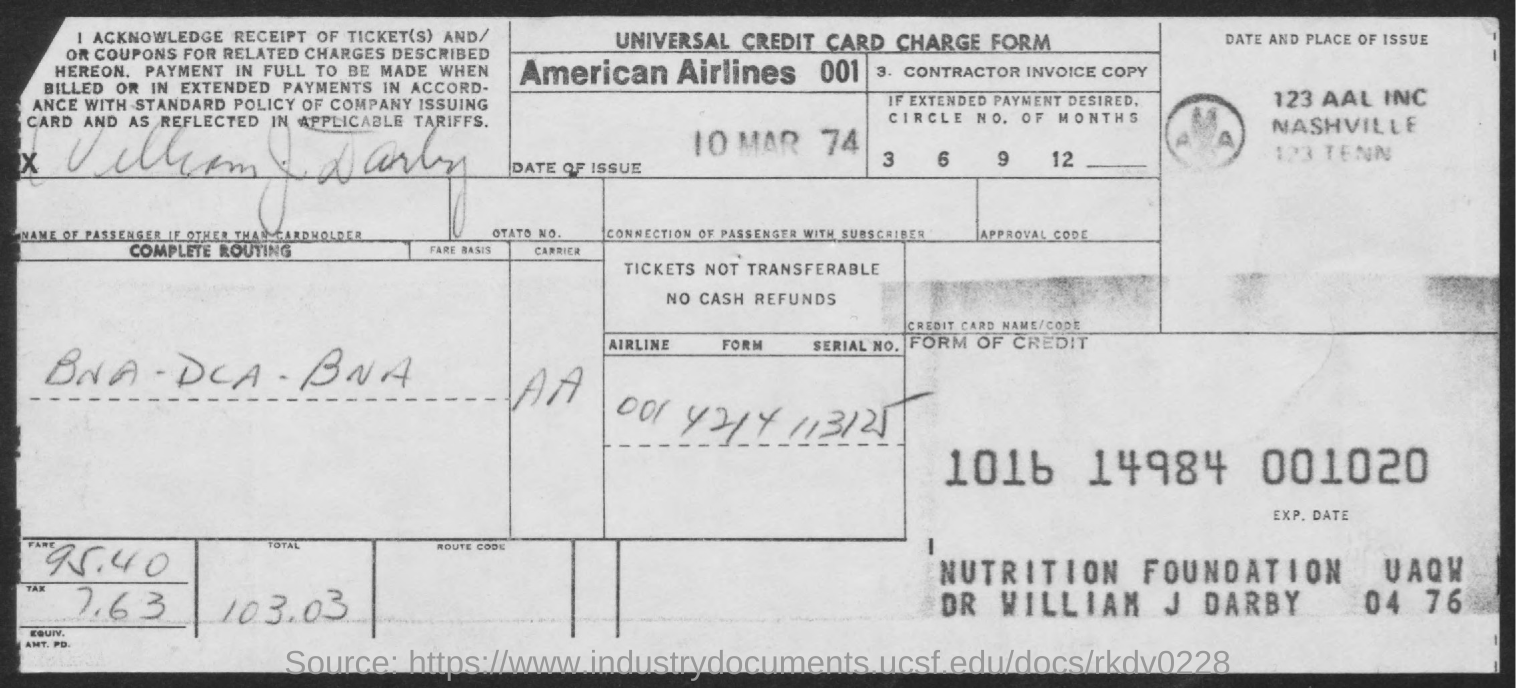Give some essential details in this illustration. The date of issue is March 10, 1974. This form is called a universal credit card charge form. The fare is 95.40. What is the tax levied?" is a question that asks for information about a specific topic. In this case, the topic is the tax that is being levied, and the speaker is asking for more information about it. The information provided is that the tax is 7.63. The total fare is 103.03... 